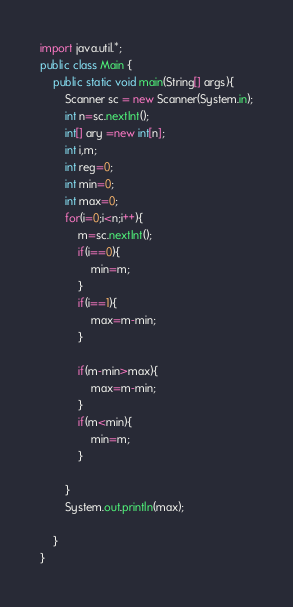<code> <loc_0><loc_0><loc_500><loc_500><_Java_>import java.util.*;
public class Main {
    public static void main(String[] args){
    	Scanner sc = new Scanner(System.in);
    	int n=sc.nextInt();
    	int[] ary =new int[n];
    	int i,m;
    	int reg=0;
    	int min=0;
    	int max=0;
    	for(i=0;i<n;i++){
    		m=sc.nextInt();
    		if(i==0){
    			min=m;
    		}
    		if(i==1){
    			max=m-min;
    		}
        
    		if(m-min>max){
    			max=m-min;
    		}
    		if(m<min){
    			min=m;
    		}
    		
    	}
    	System.out.println(max);

    }
}
</code> 